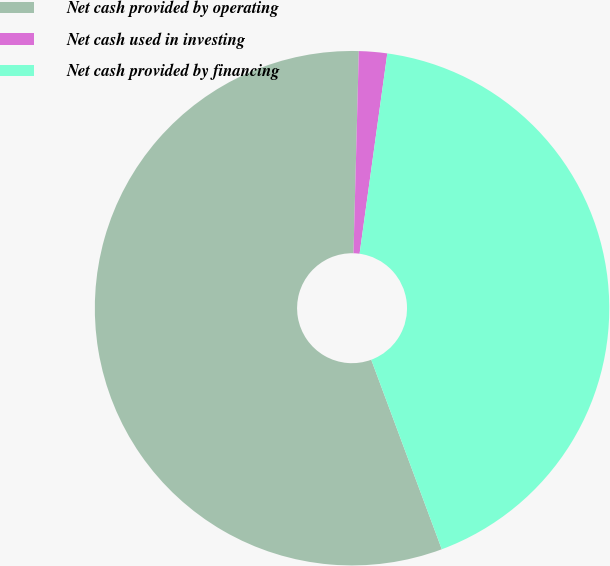Convert chart to OTSL. <chart><loc_0><loc_0><loc_500><loc_500><pie_chart><fcel>Net cash provided by operating<fcel>Net cash used in investing<fcel>Net cash provided by financing<nl><fcel>56.09%<fcel>1.77%<fcel>42.14%<nl></chart> 